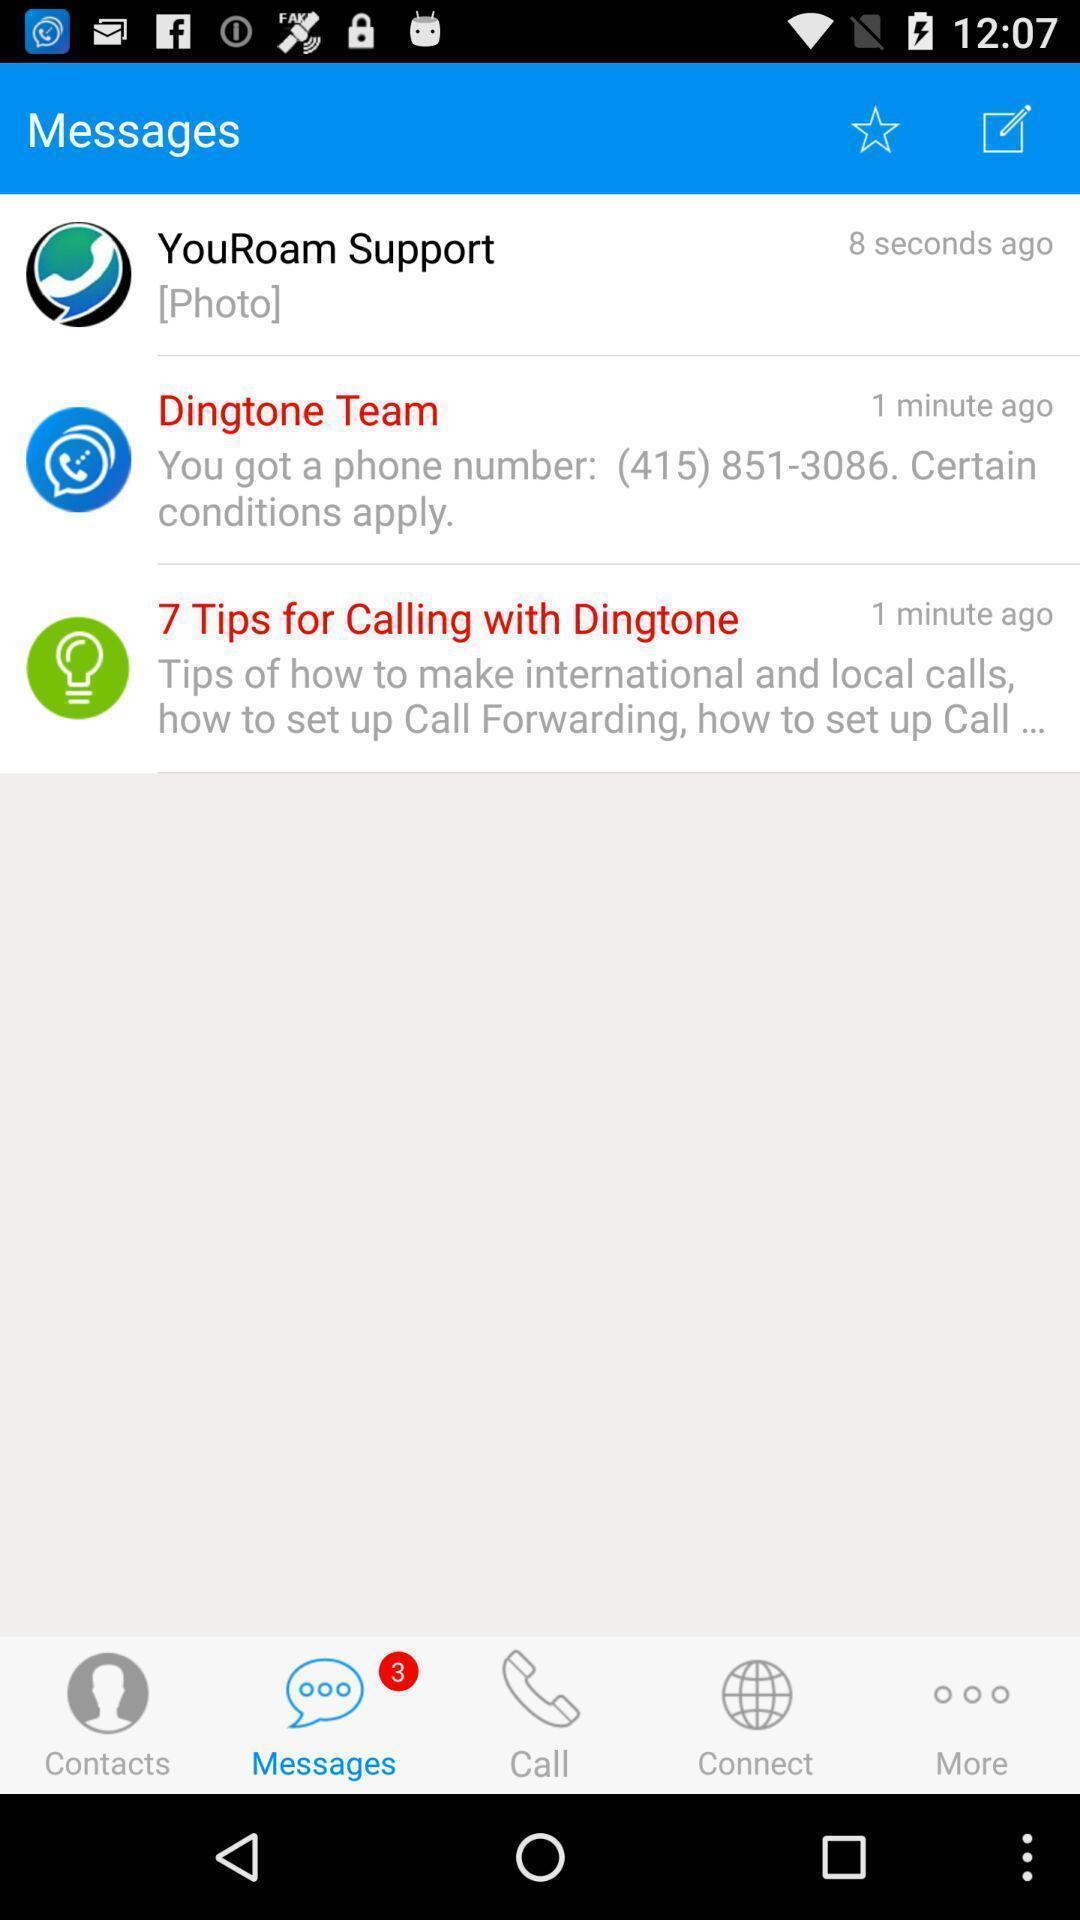Describe the visual elements of this screenshot. Screen displaying the message page. 